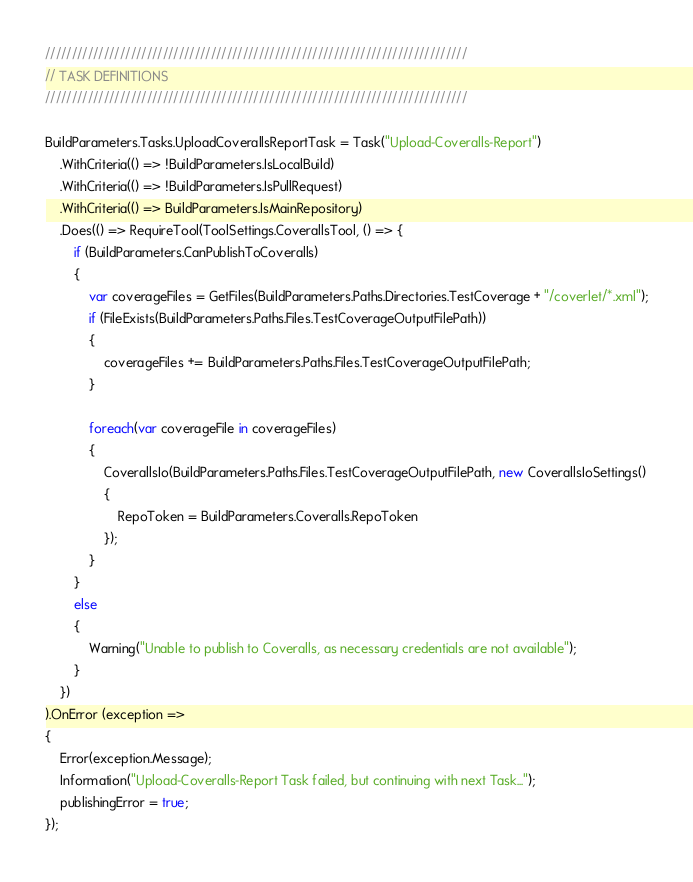Convert code to text. <code><loc_0><loc_0><loc_500><loc_500><_C#_>///////////////////////////////////////////////////////////////////////////////
// TASK DEFINITIONS
///////////////////////////////////////////////////////////////////////////////

BuildParameters.Tasks.UploadCoverallsReportTask = Task("Upload-Coveralls-Report")
    .WithCriteria(() => !BuildParameters.IsLocalBuild)
    .WithCriteria(() => !BuildParameters.IsPullRequest)
    .WithCriteria(() => BuildParameters.IsMainRepository)
    .Does(() => RequireTool(ToolSettings.CoverallsTool, () => {
        if (BuildParameters.CanPublishToCoveralls)
        {
            var coverageFiles = GetFiles(BuildParameters.Paths.Directories.TestCoverage + "/coverlet/*.xml");
            if (FileExists(BuildParameters.Paths.Files.TestCoverageOutputFilePath))
            {
                coverageFiles += BuildParameters.Paths.Files.TestCoverageOutputFilePath;
            }

            foreach(var coverageFile in coverageFiles)
            {
                CoverallsIo(BuildParameters.Paths.Files.TestCoverageOutputFilePath, new CoverallsIoSettings()
                {
                    RepoToken = BuildParameters.Coveralls.RepoToken
                });
            }
        }
        else
        {
            Warning("Unable to publish to Coveralls, as necessary credentials are not available");
        }
    })
).OnError (exception =>
{
    Error(exception.Message);
    Information("Upload-Coveralls-Report Task failed, but continuing with next Task...");
    publishingError = true;
});
</code> 